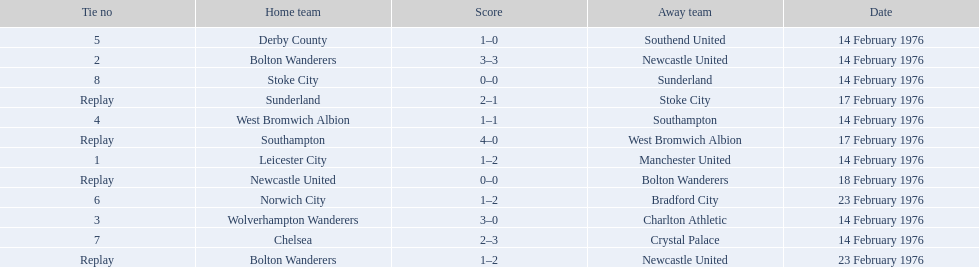How many teams played on february 14th, 1976? 7. 